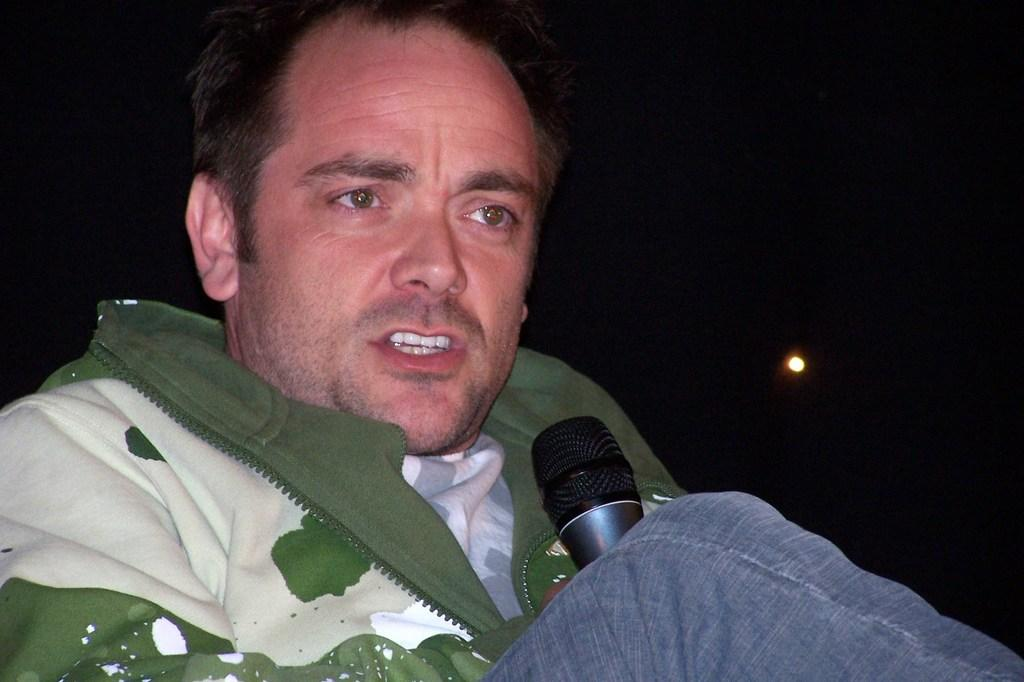What is the main subject of the image? There is a person in the image. What is the person wearing? The person is wearing a green and white jacket and blue jeans. What object is the person holding? The person is holding a microphone. What is the person doing with the microphone? The person is talking. How many feet does the person have in the image? The number of feet the person has cannot be determined from the image, as only the upper body is visible. What type of breath is the person taking in the image? There is no indication of the person's breathing in the image, so it cannot be determined. 